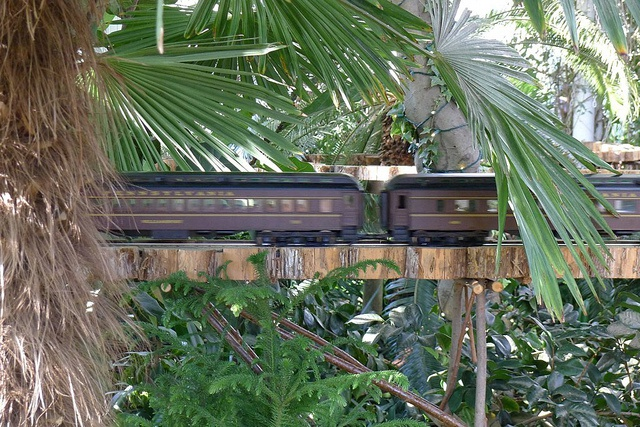Describe the objects in this image and their specific colors. I can see a train in maroon, gray, black, green, and darkgray tones in this image. 